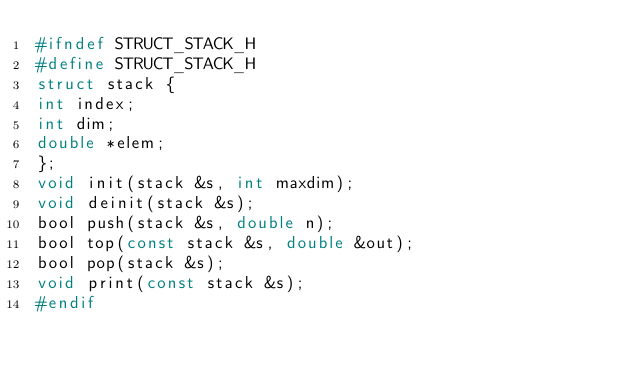<code> <loc_0><loc_0><loc_500><loc_500><_C_>#ifndef STRUCT_STACK_H
#define STRUCT_STACK_H
struct stack {
int index;
int dim;
double *elem;
};
void init(stack &s, int maxdim);
void deinit(stack &s);
bool push(stack &s, double n);
bool top(const stack &s, double &out);
bool pop(stack &s);
void print(const stack &s);
#endif</code> 